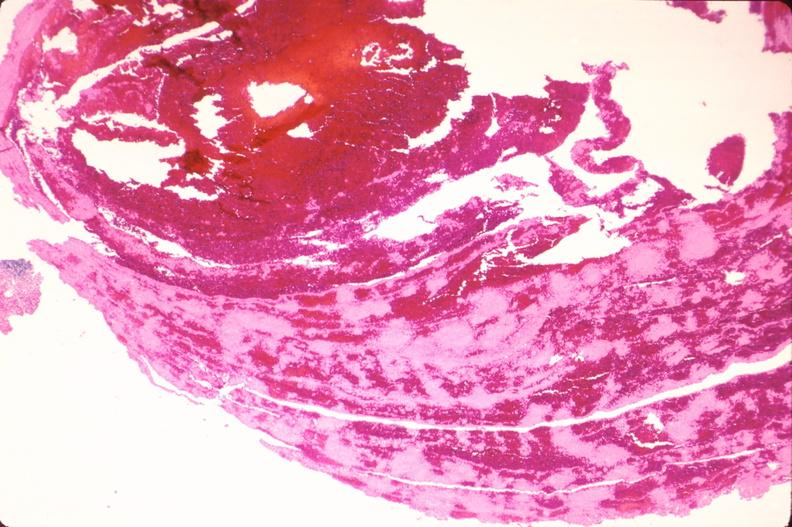s cardiovascular present?
Answer the question using a single word or phrase. Yes 